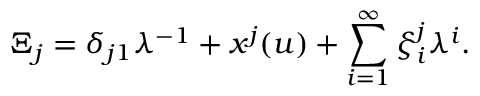Convert formula to latex. <formula><loc_0><loc_0><loc_500><loc_500>\Xi _ { j } = \delta _ { j 1 } \lambda ^ { - 1 } + x ^ { j } ( u ) + \sum _ { i = 1 } ^ { \infty } \xi _ { i } ^ { j } \lambda ^ { i } .</formula> 